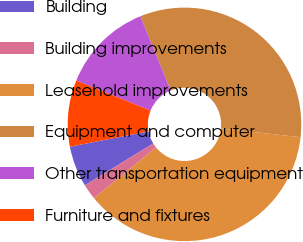Convert chart to OTSL. <chart><loc_0><loc_0><loc_500><loc_500><pie_chart><fcel>Building<fcel>Building improvements<fcel>Leasehold improvements<fcel>Equipment and computer<fcel>Other transportation equipment<fcel>Furniture and fixtures<nl><fcel>5.67%<fcel>2.15%<fcel>37.36%<fcel>32.91%<fcel>12.71%<fcel>9.19%<nl></chart> 